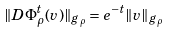Convert formula to latex. <formula><loc_0><loc_0><loc_500><loc_500>\| D \Phi _ { \rho } ^ { t } ( v ) \| _ { g _ { \rho } } = e ^ { - t } \| v \| _ { g _ { \rho } }</formula> 